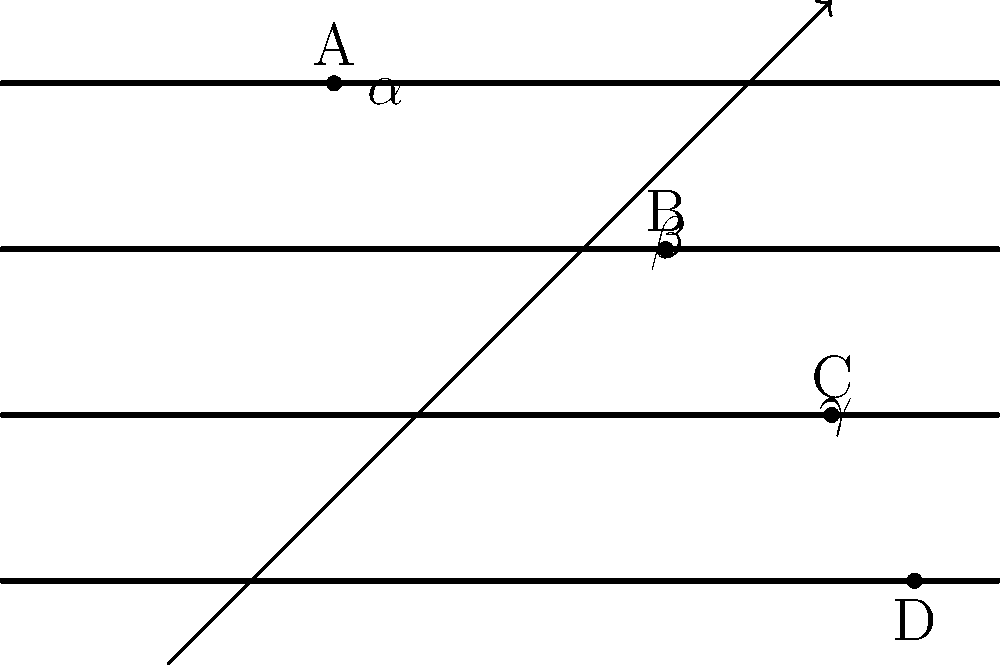In your ASMR video editing software, you notice that the audio tracks are represented by parallel lines, similar to the diagram. A transversal line crosses these tracks, creating angles $\alpha$, $\beta$, and $\gamma$ as shown. If $\alpha = 60°$ and $\beta = 120°$, what is the value of $\gamma$? Let's approach this step-by-step:

1) First, recall that when a transversal crosses parallel lines, corresponding angles are equal. This means that all angles in the same position (like $\alpha$) will be equal across all parallel lines.

2) Next, remember that when a transversal crosses two lines, the angles on the same side of the transversal are supplementary (they add up to 180°).

3) We're given that $\alpha = 60°$ and $\beta = 120°$. Let's verify that they're supplementary:
   $60° + 120° = 180°$
   This checks out, confirming our parallel lines.

4) Now, because of the property of corresponding angles, the angle corresponding to $\beta$ on the next line down will also be 120°.

5) The angle $\gamma$ forms a linear pair with this 120° angle. Linear pairs are supplementary, meaning they add up to 180°.

6) Therefore, we can find $\gamma$ by subtracting 120° from 180°:
   $\gamma = 180° - 120° = 60°$

7) This result also makes sense because $\gamma$ corresponds to $\alpha$, and we know corresponding angles are equal in parallel lines.
Answer: $60°$ 